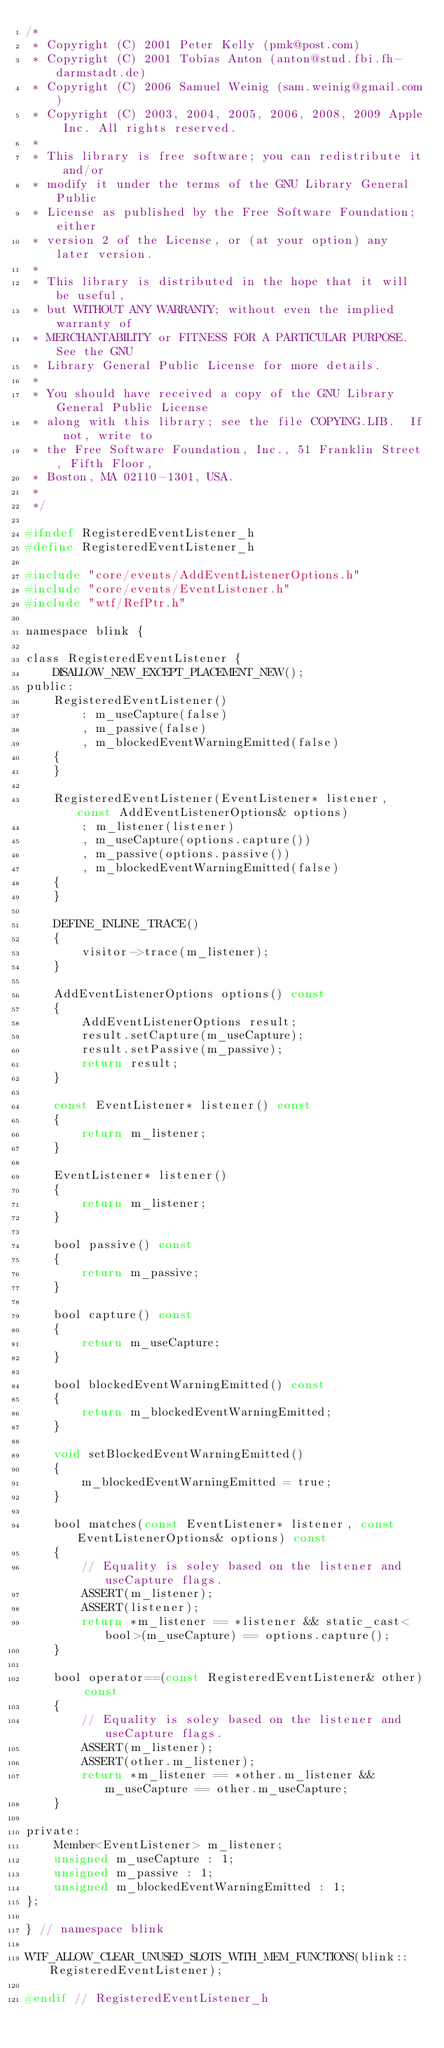<code> <loc_0><loc_0><loc_500><loc_500><_C_>/*
 * Copyright (C) 2001 Peter Kelly (pmk@post.com)
 * Copyright (C) 2001 Tobias Anton (anton@stud.fbi.fh-darmstadt.de)
 * Copyright (C) 2006 Samuel Weinig (sam.weinig@gmail.com)
 * Copyright (C) 2003, 2004, 2005, 2006, 2008, 2009 Apple Inc. All rights reserved.
 *
 * This library is free software; you can redistribute it and/or
 * modify it under the terms of the GNU Library General Public
 * License as published by the Free Software Foundation; either
 * version 2 of the License, or (at your option) any later version.
 *
 * This library is distributed in the hope that it will be useful,
 * but WITHOUT ANY WARRANTY; without even the implied warranty of
 * MERCHANTABILITY or FITNESS FOR A PARTICULAR PURPOSE.  See the GNU
 * Library General Public License for more details.
 *
 * You should have received a copy of the GNU Library General Public License
 * along with this library; see the file COPYING.LIB.  If not, write to
 * the Free Software Foundation, Inc., 51 Franklin Street, Fifth Floor,
 * Boston, MA 02110-1301, USA.
 *
 */

#ifndef RegisteredEventListener_h
#define RegisteredEventListener_h

#include "core/events/AddEventListenerOptions.h"
#include "core/events/EventListener.h"
#include "wtf/RefPtr.h"

namespace blink {

class RegisteredEventListener {
    DISALLOW_NEW_EXCEPT_PLACEMENT_NEW();
public:
    RegisteredEventListener()
        : m_useCapture(false)
        , m_passive(false)
        , m_blockedEventWarningEmitted(false)
    {
    }

    RegisteredEventListener(EventListener* listener, const AddEventListenerOptions& options)
        : m_listener(listener)
        , m_useCapture(options.capture())
        , m_passive(options.passive())
        , m_blockedEventWarningEmitted(false)
    {
    }

    DEFINE_INLINE_TRACE()
    {
        visitor->trace(m_listener);
    }

    AddEventListenerOptions options() const
    {
        AddEventListenerOptions result;
        result.setCapture(m_useCapture);
        result.setPassive(m_passive);
        return result;
    }

    const EventListener* listener() const
    {
        return m_listener;
    }

    EventListener* listener()
    {
        return m_listener;
    }

    bool passive() const
    {
        return m_passive;
    }

    bool capture() const
    {
        return m_useCapture;
    }

    bool blockedEventWarningEmitted() const
    {
        return m_blockedEventWarningEmitted;
    }

    void setBlockedEventWarningEmitted()
    {
        m_blockedEventWarningEmitted = true;
    }

    bool matches(const EventListener* listener, const EventListenerOptions& options) const
    {
        // Equality is soley based on the listener and useCapture flags.
        ASSERT(m_listener);
        ASSERT(listener);
        return *m_listener == *listener && static_cast<bool>(m_useCapture) == options.capture();
    }

    bool operator==(const RegisteredEventListener& other) const
    {
        // Equality is soley based on the listener and useCapture flags.
        ASSERT(m_listener);
        ASSERT(other.m_listener);
        return *m_listener == *other.m_listener && m_useCapture == other.m_useCapture;
    }

private:
    Member<EventListener> m_listener;
    unsigned m_useCapture : 1;
    unsigned m_passive : 1;
    unsigned m_blockedEventWarningEmitted : 1;
};

} // namespace blink

WTF_ALLOW_CLEAR_UNUSED_SLOTS_WITH_MEM_FUNCTIONS(blink::RegisteredEventListener);

#endif // RegisteredEventListener_h
</code> 